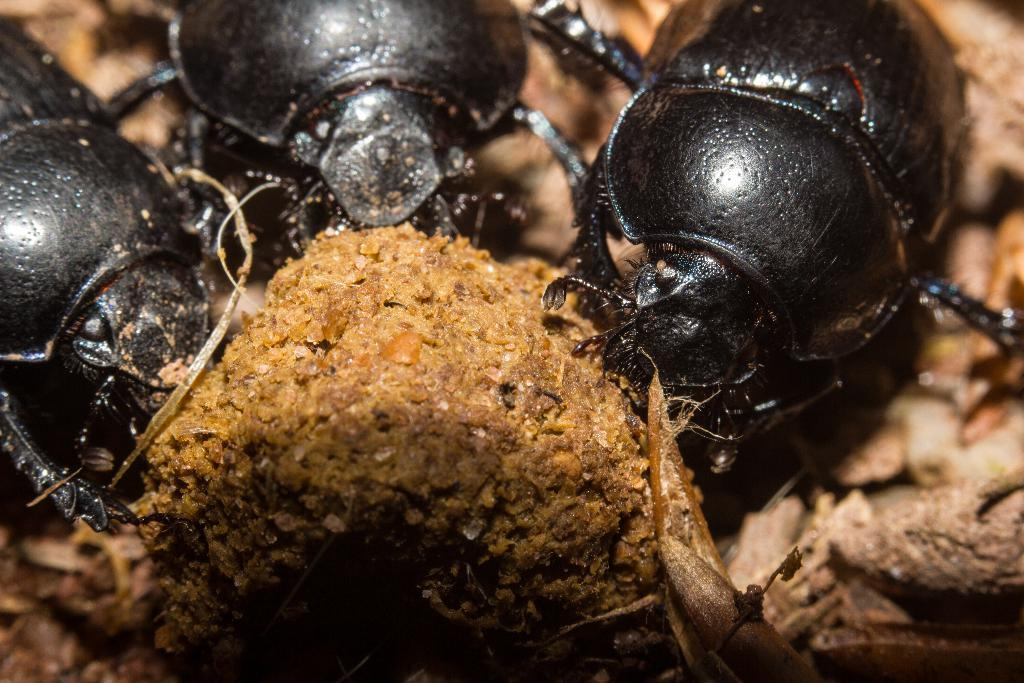How many beetles are present in the image? There are three beetles in the image. What color are the beetles? The beetles are black in color. Can you describe the background of the image? The background of the image appears blurry. What does the image resemble? The image resembles a dried leaf. How does the airplane change the color of the beetles in the image? There is no airplane present in the image, and therefore it cannot change the color of the beetles. 